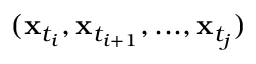Convert formula to latex. <formula><loc_0><loc_0><loc_500><loc_500>( x _ { t _ { i } } , x _ { t _ { i + 1 } } , \dots , x _ { t _ { j } } )</formula> 